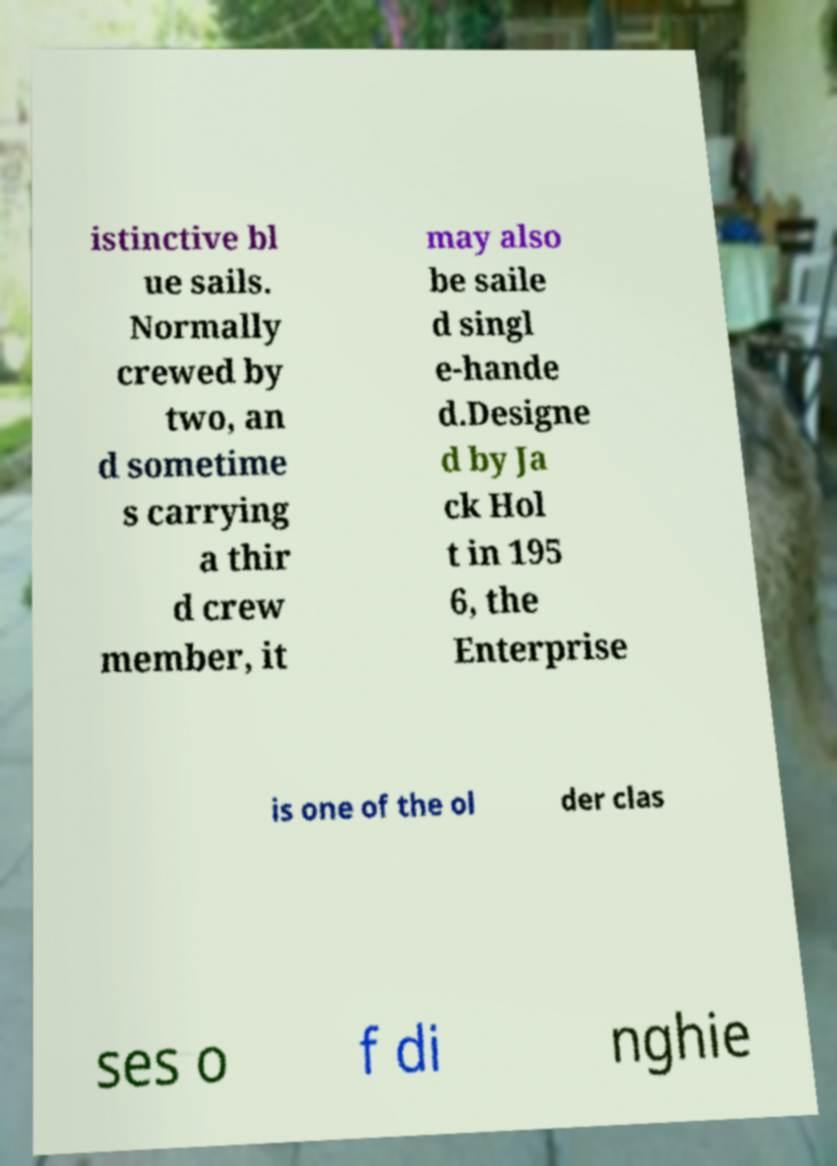Please read and relay the text visible in this image. What does it say? istinctive bl ue sails. Normally crewed by two, an d sometime s carrying a thir d crew member, it may also be saile d singl e-hande d.Designe d by Ja ck Hol t in 195 6, the Enterprise is one of the ol der clas ses o f di nghie 